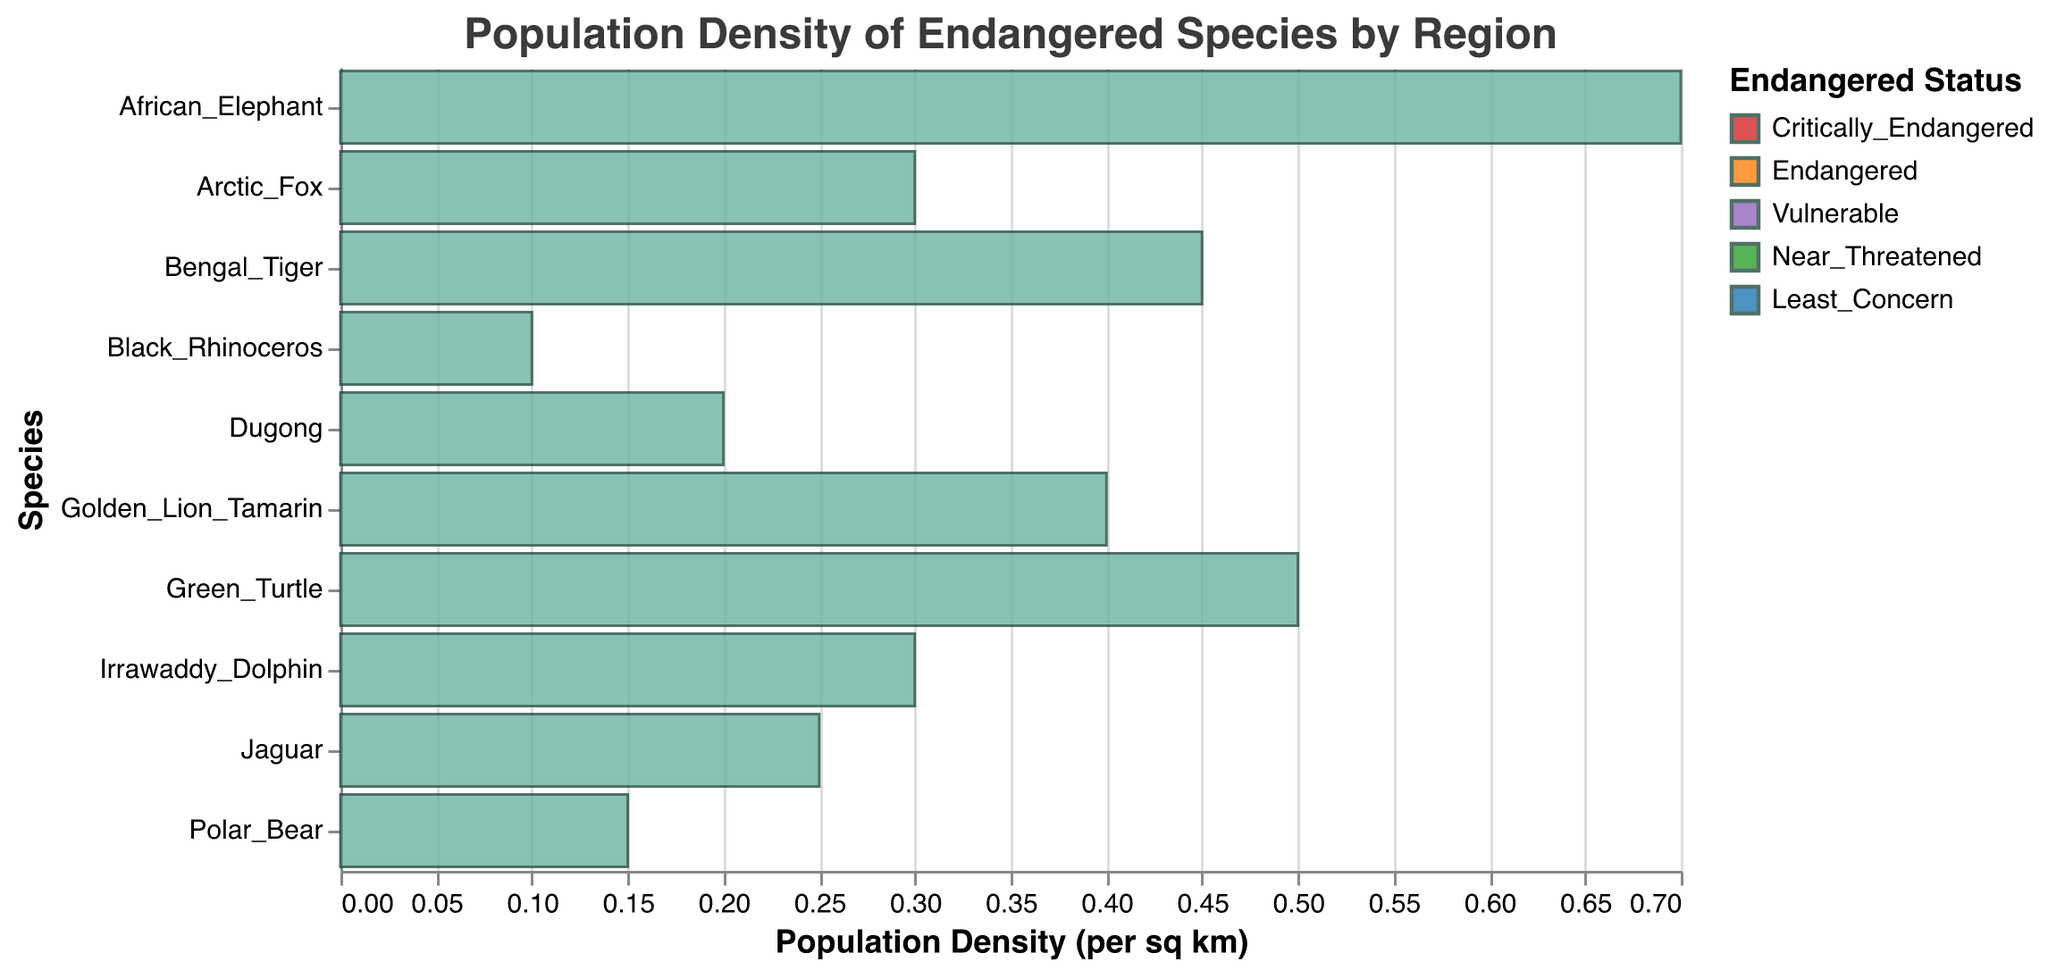What's the title of the figure? The title of the figure is shown at the top of the chart.
Answer: Population Density of Endangered Species by Region Which species has the highest population density in the Serengeti? To find this, we look at the bars corresponding to species in the Serengeti region and compare their heights. The African Elephant has the highest population density of 0.7.
Answer: African Elephant What is the population density of the Golden Lion Tamarin? Locate the bar for the Golden Lion Tamarin species. The height of this bar tells us the population density, which is 0.4 per sq km.
Answer: 0.4 Which species in the figure have a "Critically Endangered" status? Identify the bars colored in the shade representing "Critically Endangered" in the legend. The species with this status are the Golden Lion Tamarin and Black Rhinoceros.
Answer: Golden Lion Tamarin, Black Rhinoceros How does the population density of the Bengal Tiger compare to that of the Polar Bear? Locate the bars for the Bengal Tiger and Polar Bear and compare their heights. The Bengal Tiger has a population density of 0.45, while the Polar Bear's is 0.15. Bengal Tiger has a higher density.
Answer: Bengal Tiger has a higher density What's the average population density of species in the Great Barrier Reef and Arctic regions combined? Add the population densities of species in the Great Barrier Reef (0.5 + 0.2) and Arctic (0.15 + 0.3), then find the average by dividing the sum by the number of species (4). (0.5 + 0.2 + 0.15 + 0.3 = 1.15)/4 = 0.2875
Answer: 0.2875 Which region has the species with the lowest population density? Find the species with the lowest population density by comparing all bars, then determine the region of this species. The Black Rhinoceros in the Serengeti has the lowest density at 0.1 per sq km.
Answer: Serengeti How many species listed are tagged as "Vulnerable"? Count the bars that are colored in the shade representing "Vulnerable" from the legend. These are African Elephant, Dugong, Irrawaddy Dolphin, and Polar Bear.
Answer: 4 What can you infer about the average population density of species in the Sundarbans compared to other regions? Calculate the average population density of species in the Sundarbans (0.45 for Bengal Tiger + 0.3 for Irrawaddy Dolphin = 0.75, average = 0.75/2 = 0.375). Compare this with the average densities from other regions by calculating similarly. Sundarbans has a higher average than Great Barrier Reef, Arctic, but lower than Serengeti.
Answer: Higher than Great Barrier Reef and Arctic, lower than Serengeti 